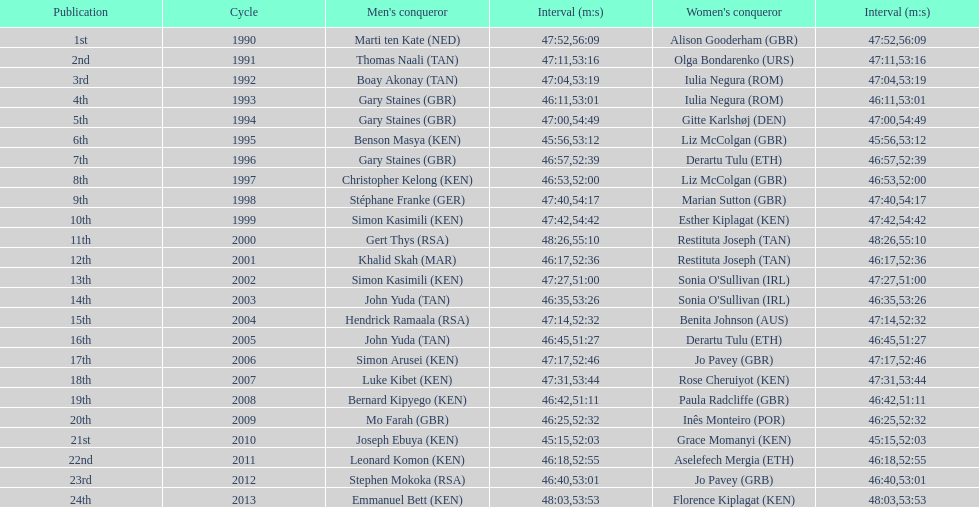Parse the table in full. {'header': ['Publication', 'Cycle', "Men's conqueror", 'Interval (m:s)', "Women's conqueror", 'Interval (m:s)'], 'rows': [['1st', '1990', 'Marti ten Kate\xa0(NED)', '47:52', 'Alison Gooderham\xa0(GBR)', '56:09'], ['2nd', '1991', 'Thomas Naali\xa0(TAN)', '47:11', 'Olga Bondarenko\xa0(URS)', '53:16'], ['3rd', '1992', 'Boay Akonay\xa0(TAN)', '47:04', 'Iulia Negura\xa0(ROM)', '53:19'], ['4th', '1993', 'Gary Staines\xa0(GBR)', '46:11', 'Iulia Negura\xa0(ROM)', '53:01'], ['5th', '1994', 'Gary Staines\xa0(GBR)', '47:00', 'Gitte Karlshøj\xa0(DEN)', '54:49'], ['6th', '1995', 'Benson Masya\xa0(KEN)', '45:56', 'Liz McColgan\xa0(GBR)', '53:12'], ['7th', '1996', 'Gary Staines\xa0(GBR)', '46:57', 'Derartu Tulu\xa0(ETH)', '52:39'], ['8th', '1997', 'Christopher Kelong\xa0(KEN)', '46:53', 'Liz McColgan\xa0(GBR)', '52:00'], ['9th', '1998', 'Stéphane Franke\xa0(GER)', '47:40', 'Marian Sutton\xa0(GBR)', '54:17'], ['10th', '1999', 'Simon Kasimili\xa0(KEN)', '47:42', 'Esther Kiplagat\xa0(KEN)', '54:42'], ['11th', '2000', 'Gert Thys\xa0(RSA)', '48:26', 'Restituta Joseph\xa0(TAN)', '55:10'], ['12th', '2001', 'Khalid Skah\xa0(MAR)', '46:17', 'Restituta Joseph\xa0(TAN)', '52:36'], ['13th', '2002', 'Simon Kasimili\xa0(KEN)', '47:27', "Sonia O'Sullivan\xa0(IRL)", '51:00'], ['14th', '2003', 'John Yuda\xa0(TAN)', '46:35', "Sonia O'Sullivan\xa0(IRL)", '53:26'], ['15th', '2004', 'Hendrick Ramaala\xa0(RSA)', '47:14', 'Benita Johnson\xa0(AUS)', '52:32'], ['16th', '2005', 'John Yuda\xa0(TAN)', '46:45', 'Derartu Tulu\xa0(ETH)', '51:27'], ['17th', '2006', 'Simon Arusei\xa0(KEN)', '47:17', 'Jo Pavey\xa0(GBR)', '52:46'], ['18th', '2007', 'Luke Kibet\xa0(KEN)', '47:31', 'Rose Cheruiyot\xa0(KEN)', '53:44'], ['19th', '2008', 'Bernard Kipyego\xa0(KEN)', '46:42', 'Paula Radcliffe\xa0(GBR)', '51:11'], ['20th', '2009', 'Mo Farah\xa0(GBR)', '46:25', 'Inês Monteiro\xa0(POR)', '52:32'], ['21st', '2010', 'Joseph Ebuya\xa0(KEN)', '45:15', 'Grace Momanyi\xa0(KEN)', '52:03'], ['22nd', '2011', 'Leonard Komon\xa0(KEN)', '46:18', 'Aselefech Mergia\xa0(ETH)', '52:55'], ['23rd', '2012', 'Stephen Mokoka\xa0(RSA)', '46:40', 'Jo Pavey\xa0(GRB)', '53:01'], ['24th', '2013', 'Emmanuel Bett\xa0(KEN)', '48:03', 'Florence Kiplagat\xa0(KEN)', '53:53']]} Home many times did a single country win both the men's and women's bupa great south run? 4. 